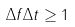Convert formula to latex. <formula><loc_0><loc_0><loc_500><loc_500>\Delta f \Delta t \geq 1</formula> 